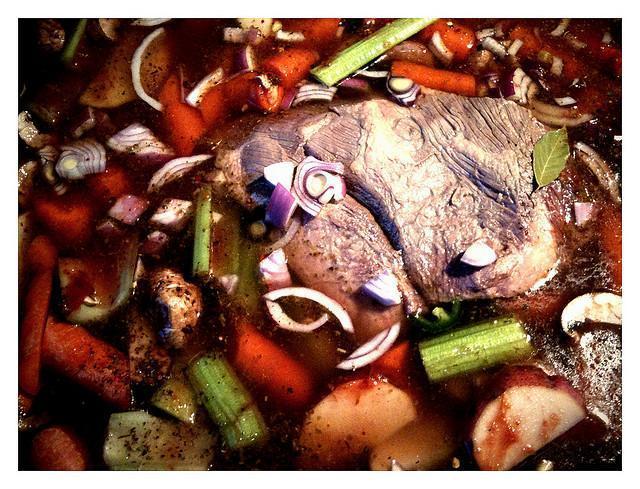How many carrots are there?
Give a very brief answer. 7. How many apples are in the picture?
Give a very brief answer. 3. 